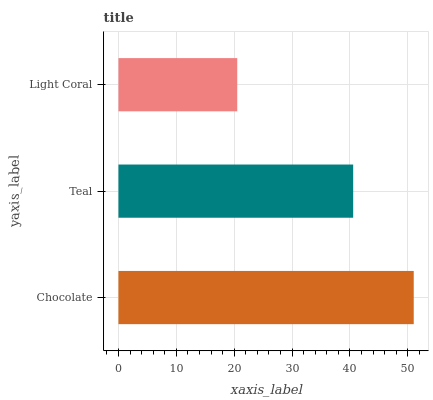Is Light Coral the minimum?
Answer yes or no. Yes. Is Chocolate the maximum?
Answer yes or no. Yes. Is Teal the minimum?
Answer yes or no. No. Is Teal the maximum?
Answer yes or no. No. Is Chocolate greater than Teal?
Answer yes or no. Yes. Is Teal less than Chocolate?
Answer yes or no. Yes. Is Teal greater than Chocolate?
Answer yes or no. No. Is Chocolate less than Teal?
Answer yes or no. No. Is Teal the high median?
Answer yes or no. Yes. Is Teal the low median?
Answer yes or no. Yes. Is Light Coral the high median?
Answer yes or no. No. Is Chocolate the low median?
Answer yes or no. No. 